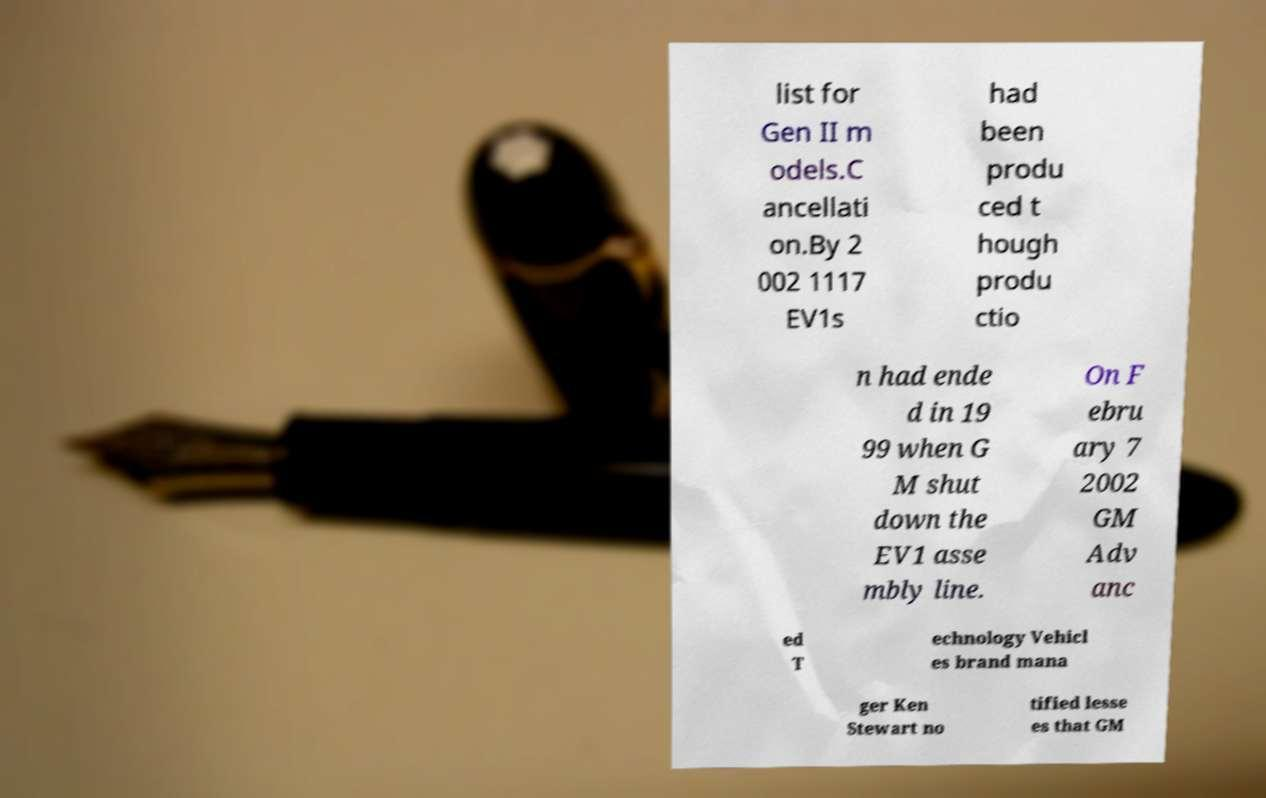Please read and relay the text visible in this image. What does it say? list for Gen II m odels.C ancellati on.By 2 002 1117 EV1s had been produ ced t hough produ ctio n had ende d in 19 99 when G M shut down the EV1 asse mbly line. On F ebru ary 7 2002 GM Adv anc ed T echnology Vehicl es brand mana ger Ken Stewart no tified lesse es that GM 